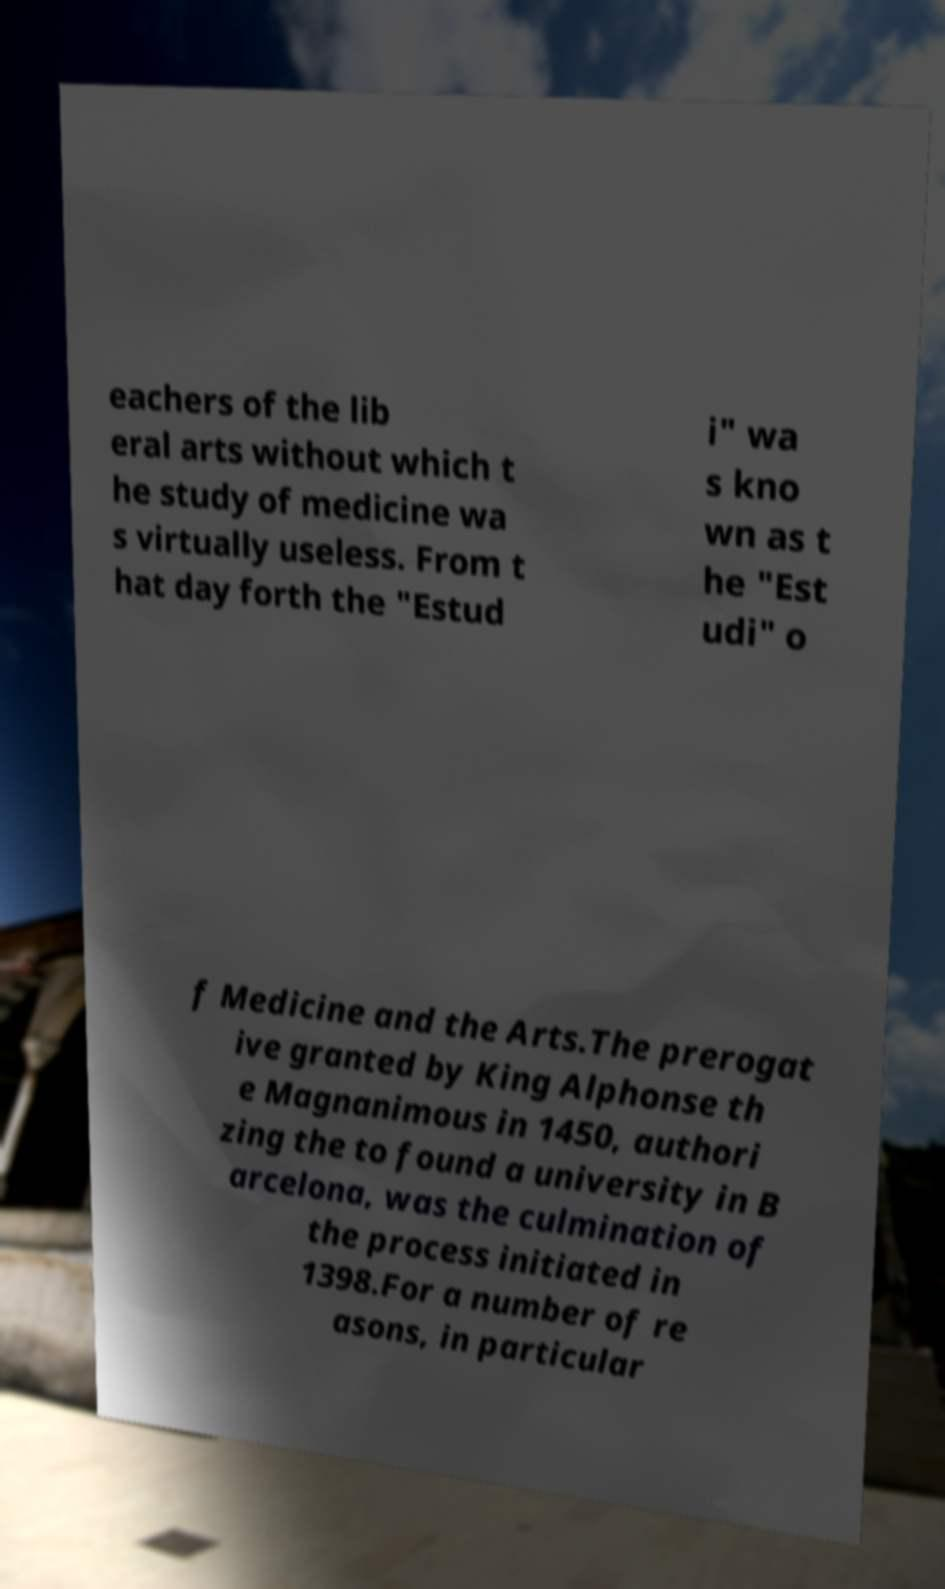Could you assist in decoding the text presented in this image and type it out clearly? eachers of the lib eral arts without which t he study of medicine wa s virtually useless. From t hat day forth the "Estud i" wa s kno wn as t he "Est udi" o f Medicine and the Arts.The prerogat ive granted by King Alphonse th e Magnanimous in 1450, authori zing the to found a university in B arcelona, was the culmination of the process initiated in 1398.For a number of re asons, in particular 